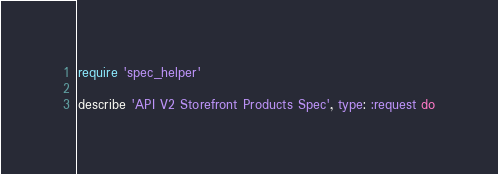<code> <loc_0><loc_0><loc_500><loc_500><_Ruby_>require 'spec_helper'

describe 'API V2 Storefront Products Spec', type: :request do</code> 